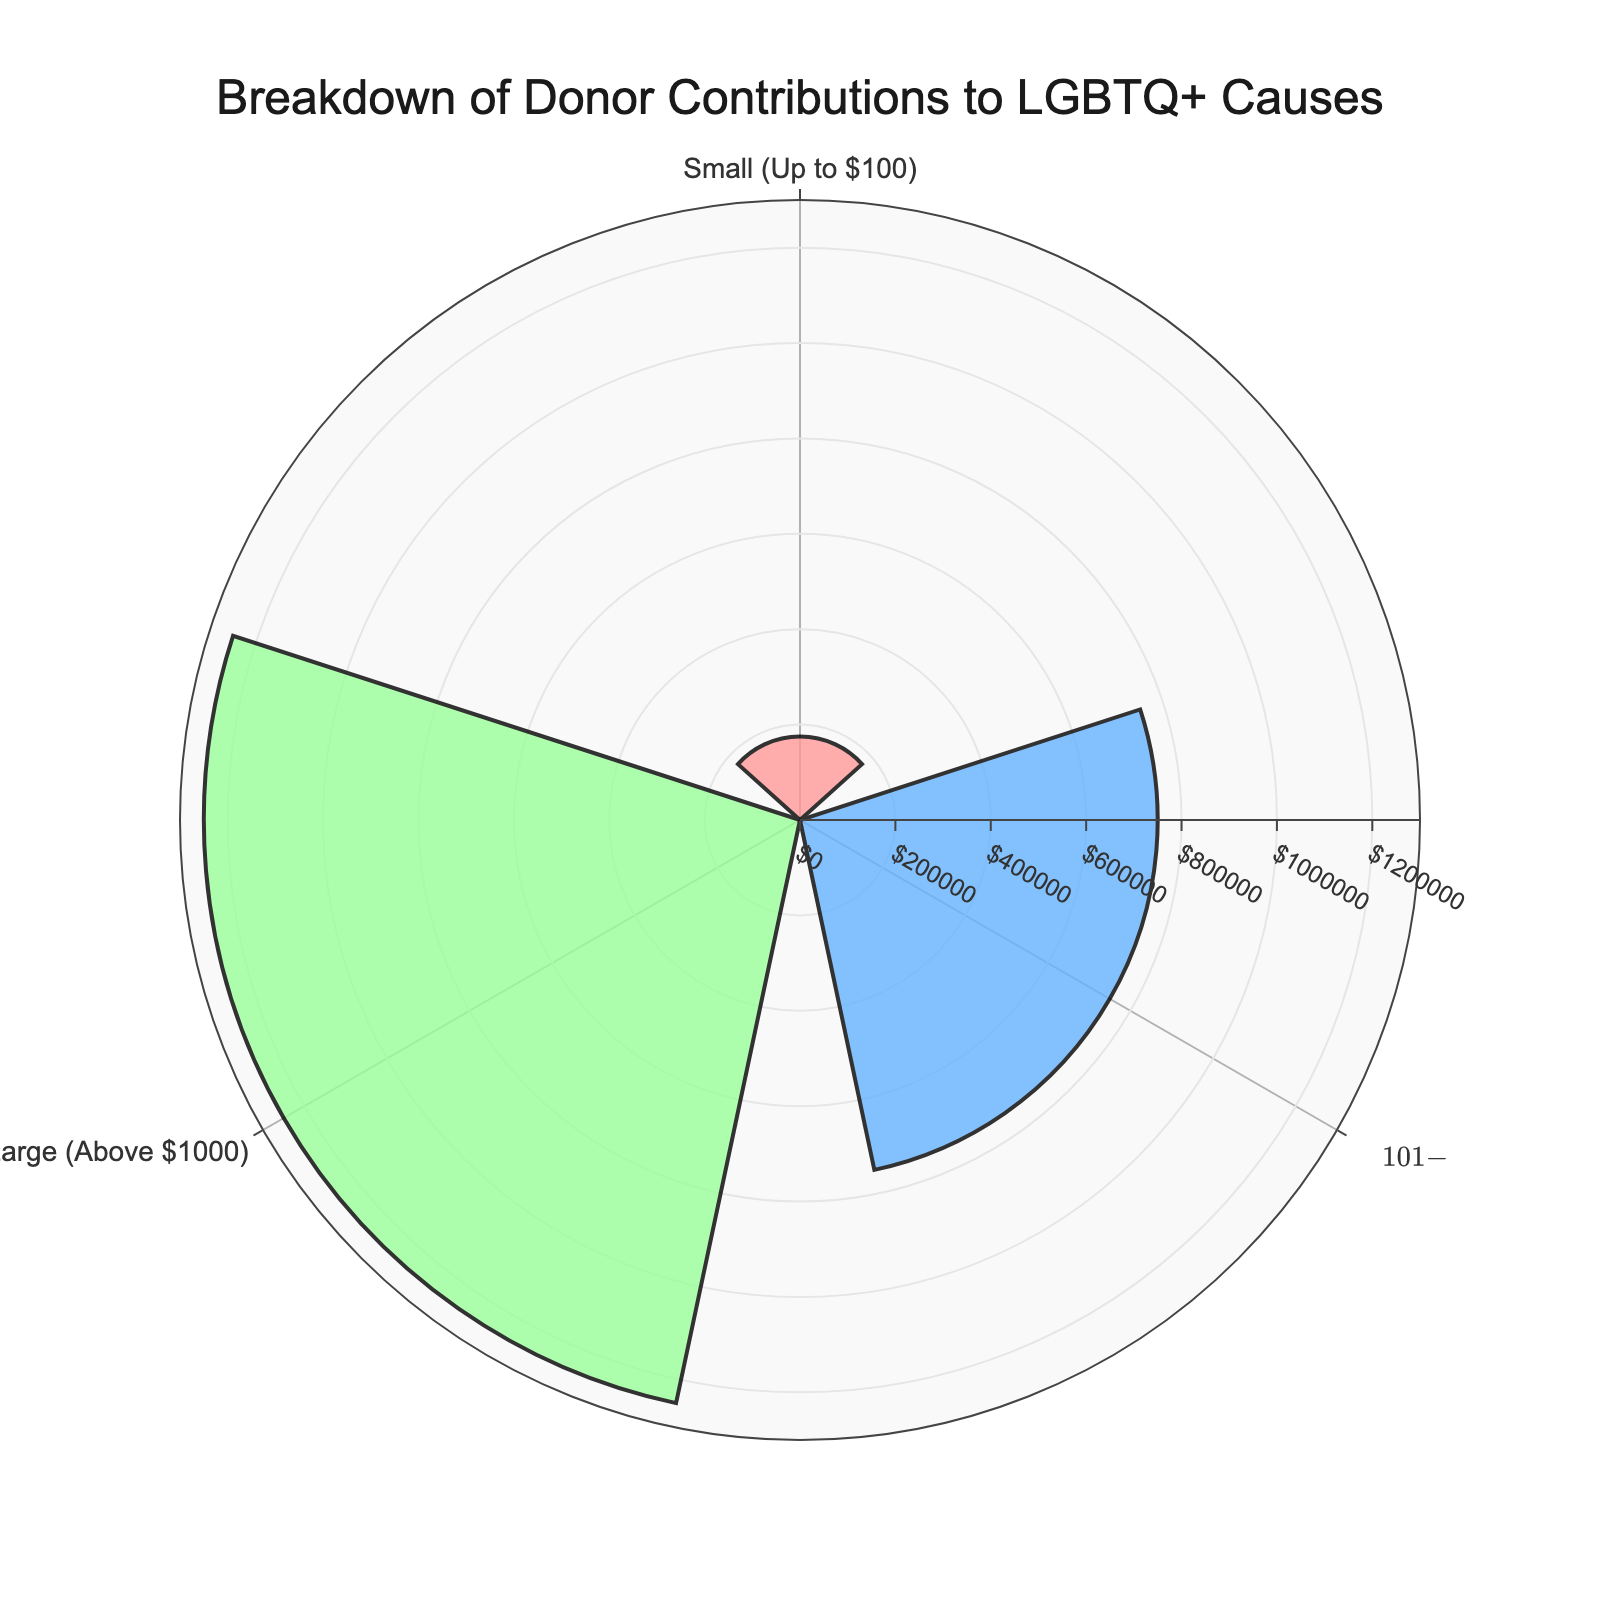What's the title of the figure? The title of the figure is usually displayed at the top of the chart. In this case, it's clearly stated at the top center of the chart.
Answer: Breakdown of Donor Contributions to LGBTQ+ Causes How many donation size categories are there in the chart? This can be determined by counting the unique donation size labels on the chart.
Answer: 3 Which donation size contributes the most to the total amount? This can be observed by looking at the donation size category with the longest bar in the rose chart.
Answer: Large (Above $1000) What percentage of the total donations is from the Medium donation size? The percentage is typically annotated in the rose chart. Look for the Medium donation size label and identify its corresponding percentage annotation.
Answer: 37.5% What is the color used for the Small donation size category in the chart? Identify the color of the bar that corresponds to the Small donation size category.
Answer: Pink Which donation size category has the smallest total amount of contributions? Compare the lengths of the bars associated with each donation size category. The category with the shortest bar has the smallest total amount.
Answer: Small (Up to $100) How do the total amounts contributed by Medium and Large donation sizes compare? Compare the lengths of the bars corresponding to the Medium and Large donation sizes on the rose chart.
Answer: The Large donation size has a greater total amount than the Medium donation size What is the total amount (USD) contributed by the Medium donation size? Check the length or the annotation for the Medium donation size category in the rose chart.
Answer: 750,000 What radial axis range is used in this chart? The radial axis range is usually indicated on the chart's radial axis.
Answer: 0 to 1,300,000 USD How many more donations are in the Small donation size category compared to the Large donation size category? Subtract the number of donations in the Large category from the number of donations in the Small category: 3500 (Small) - 250 (Large) = 3250.
Answer: 3250 